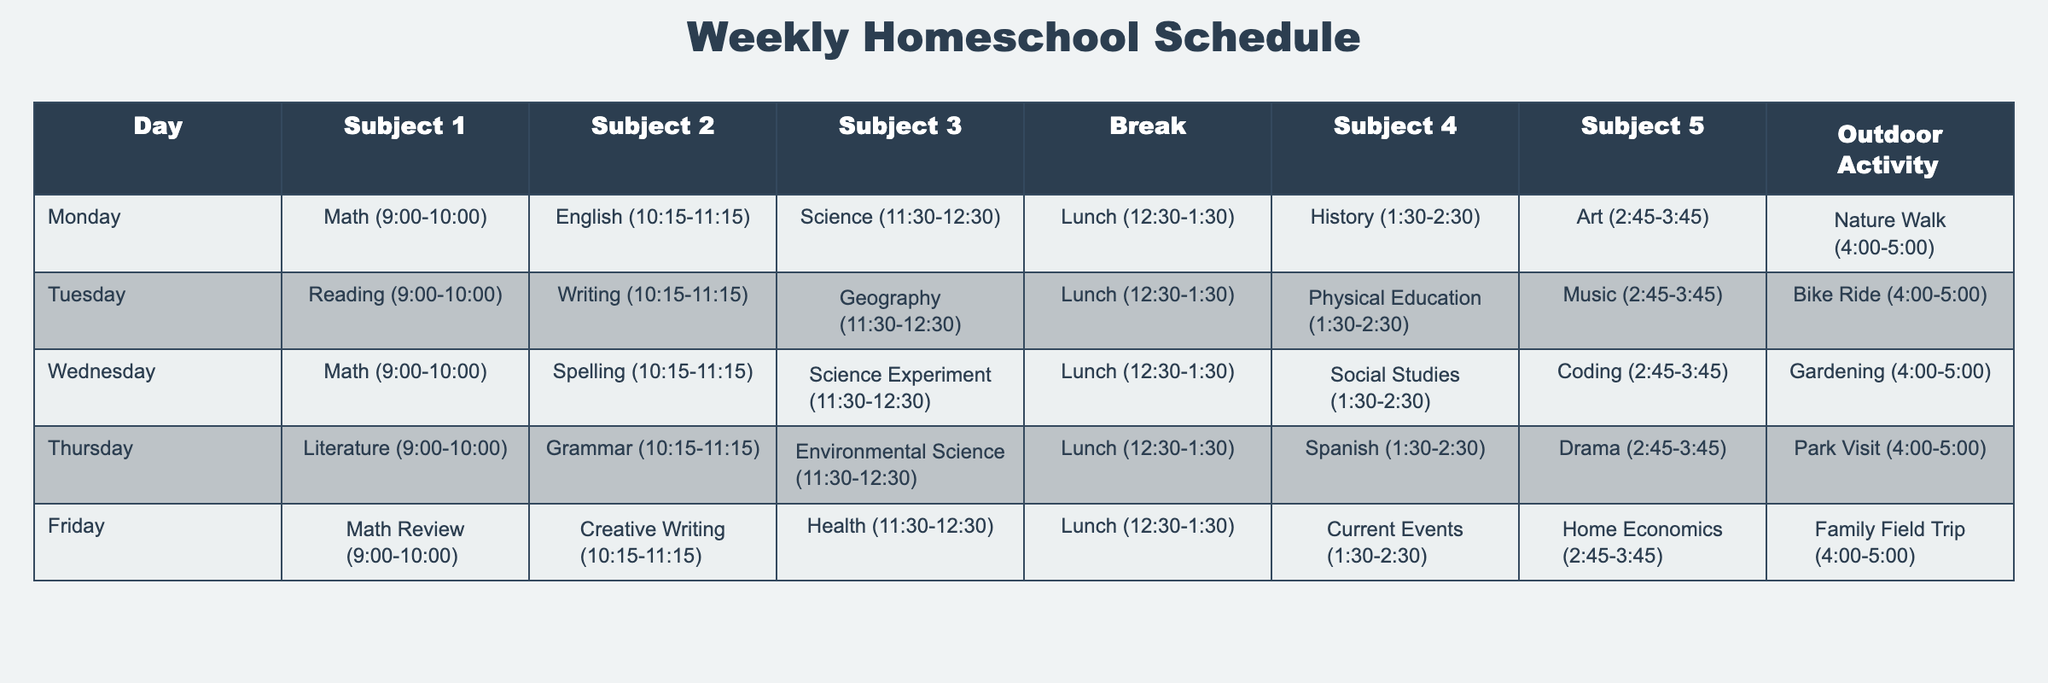What subjects are taught on Monday? The table lists the subjects for each day of the week. For Monday, the subjects are Math, English, Science, History, and Art.
Answer: Math, English, Science, History, Art What is the duration of the break on Wednesday? According to the table, each lunch break is specified as 12:30-1:30, which is consistent across all days, including Wednesday.
Answer: 1 hour Which outdoor activity is scheduled for Friday? By looking at the table, the outdoor activity listed for Friday is a Family Field Trip.
Answer: Family Field Trip Is Geography taught before or after lunch on Tuesday? In the table, Geography is listed at 11:30-12:30, which is before lunch that starts at 12:30.
Answer: Before lunch How many subjects are scheduled before the break on Thursday? The table shows three subjects scheduled before lunch on Thursday: Literature, Grammar, and Environmental Science.
Answer: 3 subjects On which day is coding taught, and at what time? The table indicates that coding is taught on Wednesday from 2:45 to 3:45.
Answer: Wednesday, 2:45-3:45 Is there any day when Science is taught at the same time as a Language subject? By examining the table, Science is taught on both Monday and Wednesday at different times, while English is taught on Monday, and Grammar is on Thursday—none coincide.
Answer: No Which subject has the earliest start time on Tuesday? Looking at the table, Reading starts at 9:00 AM, which is the earliest start time on that day.
Answer: Reading Count how many subjects are dedicated to the arts across the week. The subjects labeled as arts are Art on Monday, Music on Tuesday, and Drama on Thursday—totaling three subjects in the week.
Answer: 3 subjects On which day do students have two physical activities scheduled? The table shows Physical Education on Tuesday and an Outdoor activity, Bike Ride, on the same day, making it the only day with two physical activities scheduled.
Answer: Tuesday 